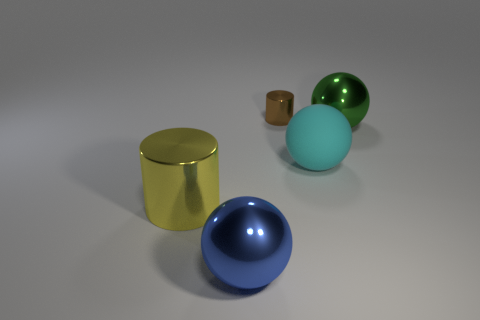What textures are visible in this image? The objects in the image display a variety of textures. The cylinder and the largest sphere have a glossy, reflective texture, while the cube and the smallest sphere have a more subdued, matte finish. The medium-sized sphere, which is cyan, looks to have a slightly roughened surface indicative of a rubber texture. 